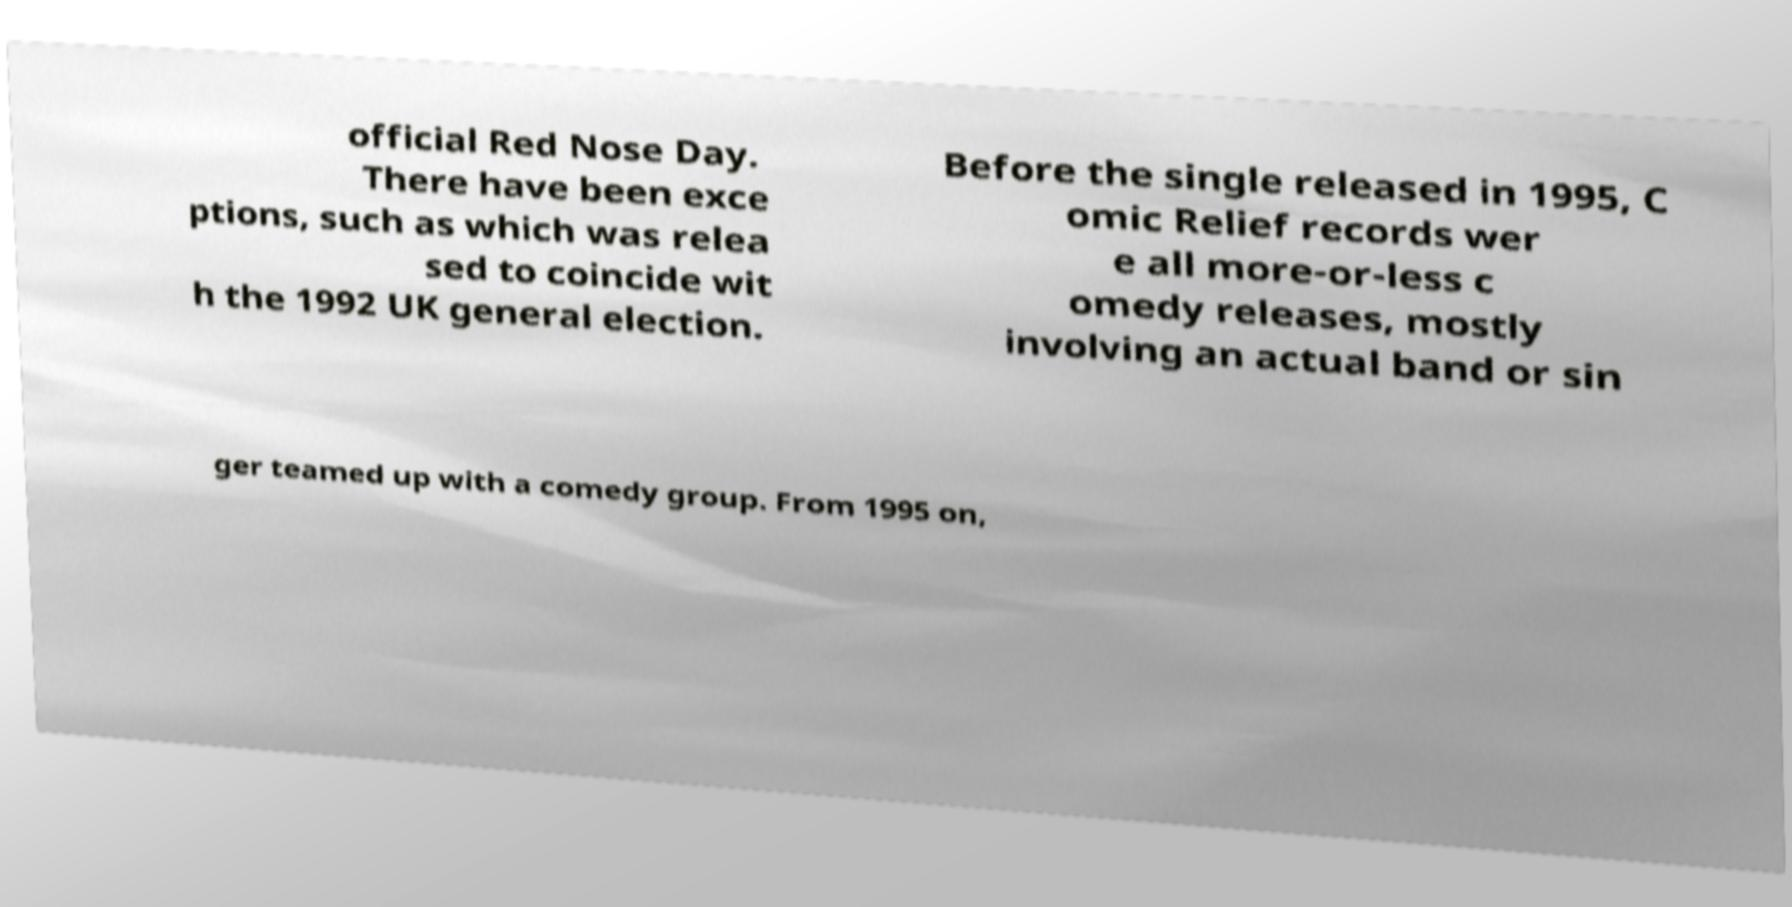Could you assist in decoding the text presented in this image and type it out clearly? official Red Nose Day. There have been exce ptions, such as which was relea sed to coincide wit h the 1992 UK general election. Before the single released in 1995, C omic Relief records wer e all more-or-less c omedy releases, mostly involving an actual band or sin ger teamed up with a comedy group. From 1995 on, 